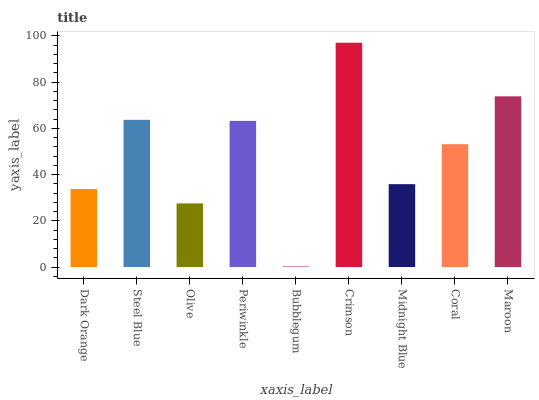Is Bubblegum the minimum?
Answer yes or no. Yes. Is Crimson the maximum?
Answer yes or no. Yes. Is Steel Blue the minimum?
Answer yes or no. No. Is Steel Blue the maximum?
Answer yes or no. No. Is Steel Blue greater than Dark Orange?
Answer yes or no. Yes. Is Dark Orange less than Steel Blue?
Answer yes or no. Yes. Is Dark Orange greater than Steel Blue?
Answer yes or no. No. Is Steel Blue less than Dark Orange?
Answer yes or no. No. Is Coral the high median?
Answer yes or no. Yes. Is Coral the low median?
Answer yes or no. Yes. Is Bubblegum the high median?
Answer yes or no. No. Is Bubblegum the low median?
Answer yes or no. No. 